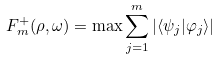<formula> <loc_0><loc_0><loc_500><loc_500>F ^ { + } _ { m } ( \rho , \omega ) = \max \sum _ { j = 1 } ^ { m } | \langle \psi _ { j } | \varphi _ { j } \rangle |</formula> 